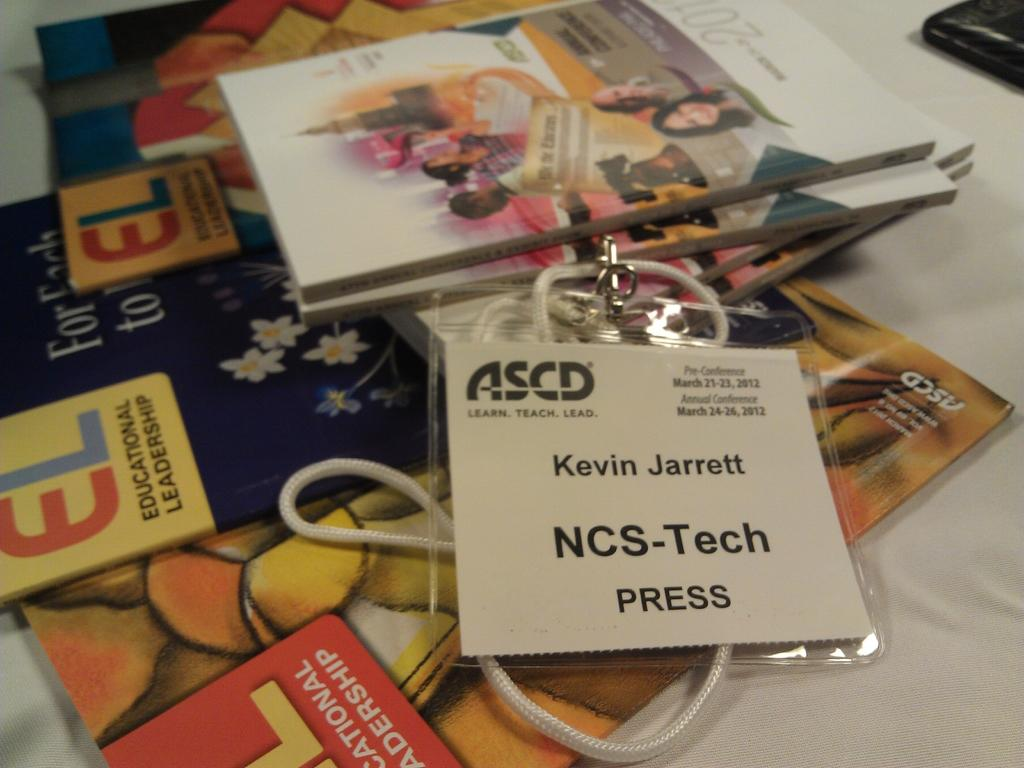<image>
Render a clear and concise summary of the photo. A nametag for Kevin Jarrett sitting on a table of pamphlets. 